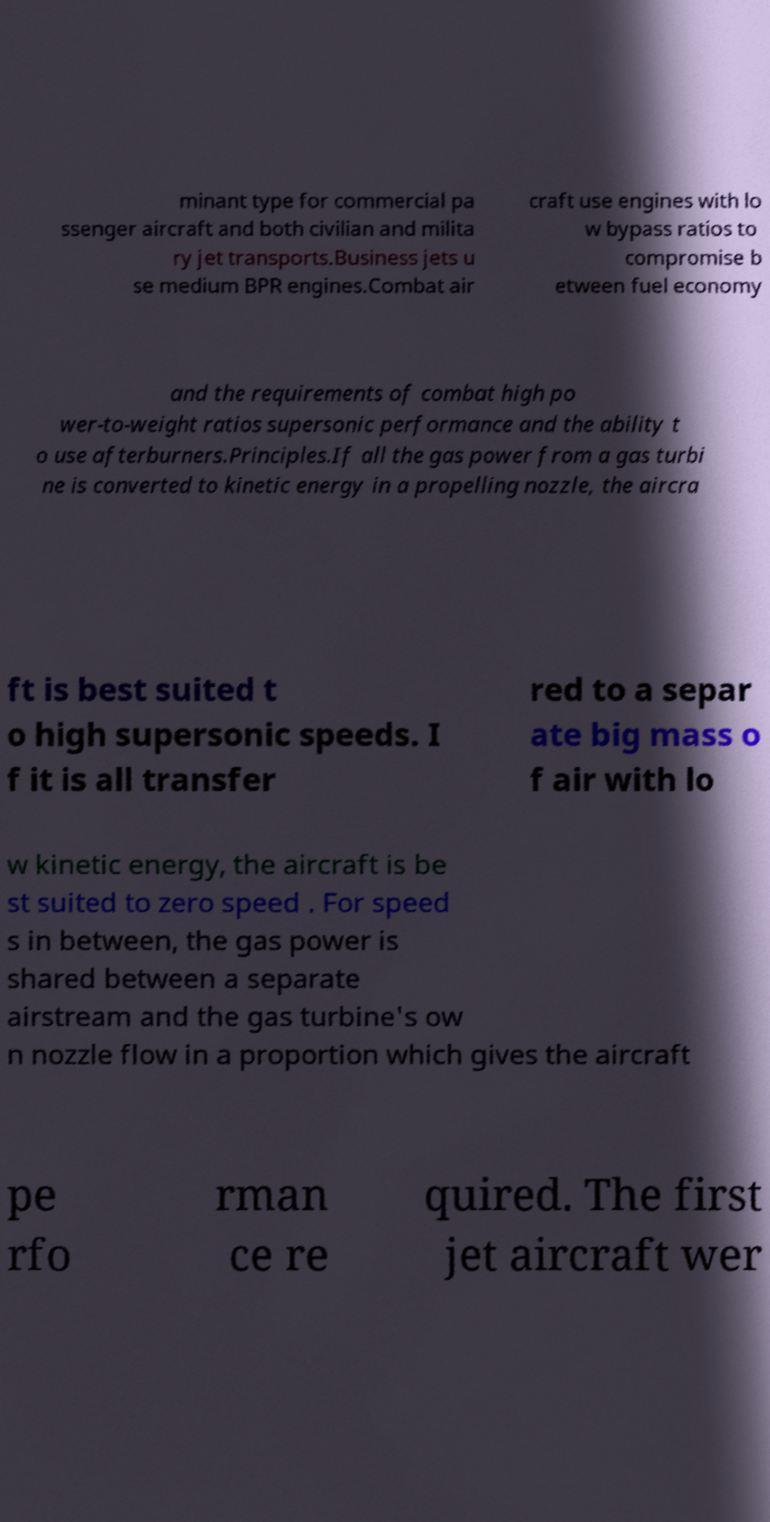For documentation purposes, I need the text within this image transcribed. Could you provide that? minant type for commercial pa ssenger aircraft and both civilian and milita ry jet transports.Business jets u se medium BPR engines.Combat air craft use engines with lo w bypass ratios to compromise b etween fuel economy and the requirements of combat high po wer-to-weight ratios supersonic performance and the ability t o use afterburners.Principles.If all the gas power from a gas turbi ne is converted to kinetic energy in a propelling nozzle, the aircra ft is best suited t o high supersonic speeds. I f it is all transfer red to a separ ate big mass o f air with lo w kinetic energy, the aircraft is be st suited to zero speed . For speed s in between, the gas power is shared between a separate airstream and the gas turbine's ow n nozzle flow in a proportion which gives the aircraft pe rfo rman ce re quired. The first jet aircraft wer 